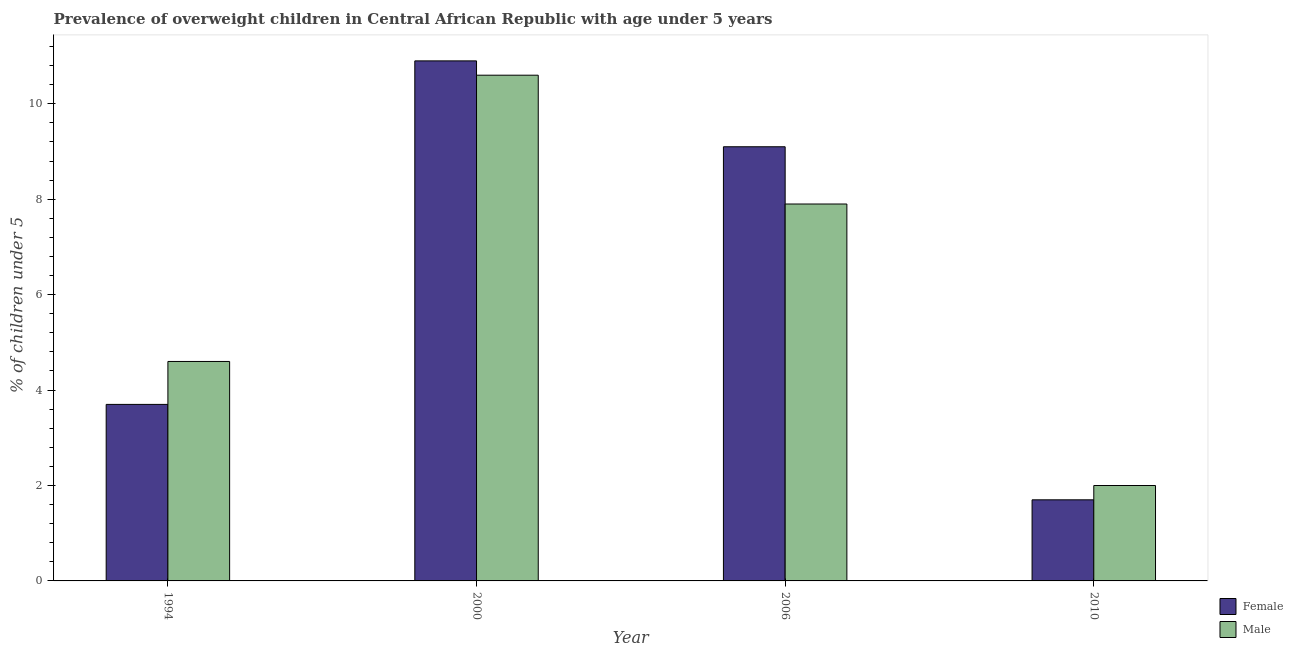How many different coloured bars are there?
Provide a short and direct response. 2. Are the number of bars per tick equal to the number of legend labels?
Make the answer very short. Yes. How many bars are there on the 1st tick from the right?
Ensure brevity in your answer.  2. What is the percentage of obese male children in 1994?
Offer a very short reply. 4.6. Across all years, what is the maximum percentage of obese female children?
Your answer should be very brief. 10.9. In which year was the percentage of obese female children maximum?
Your answer should be very brief. 2000. In which year was the percentage of obese female children minimum?
Ensure brevity in your answer.  2010. What is the total percentage of obese male children in the graph?
Your answer should be compact. 25.1. What is the difference between the percentage of obese male children in 1994 and that in 2010?
Your answer should be compact. 2.6. What is the difference between the percentage of obese male children in 1994 and the percentage of obese female children in 2006?
Keep it short and to the point. -3.3. What is the average percentage of obese male children per year?
Make the answer very short. 6.28. In how many years, is the percentage of obese female children greater than 1.6 %?
Offer a very short reply. 4. What is the ratio of the percentage of obese male children in 2000 to that in 2006?
Make the answer very short. 1.34. What is the difference between the highest and the second highest percentage of obese female children?
Keep it short and to the point. 1.8. What is the difference between the highest and the lowest percentage of obese male children?
Provide a short and direct response. 8.6. What does the 2nd bar from the left in 2006 represents?
Provide a succinct answer. Male. How many bars are there?
Your answer should be compact. 8. Are all the bars in the graph horizontal?
Make the answer very short. No. How many years are there in the graph?
Ensure brevity in your answer.  4. Are the values on the major ticks of Y-axis written in scientific E-notation?
Provide a short and direct response. No. Does the graph contain any zero values?
Keep it short and to the point. No. Does the graph contain grids?
Your answer should be very brief. No. Where does the legend appear in the graph?
Your answer should be compact. Bottom right. What is the title of the graph?
Your answer should be very brief. Prevalence of overweight children in Central African Republic with age under 5 years. What is the label or title of the Y-axis?
Offer a terse response.  % of children under 5. What is the  % of children under 5 in Female in 1994?
Provide a short and direct response. 3.7. What is the  % of children under 5 of Male in 1994?
Offer a terse response. 4.6. What is the  % of children under 5 of Female in 2000?
Provide a succinct answer. 10.9. What is the  % of children under 5 of Male in 2000?
Ensure brevity in your answer.  10.6. What is the  % of children under 5 of Female in 2006?
Provide a short and direct response. 9.1. What is the  % of children under 5 of Male in 2006?
Your response must be concise. 7.9. What is the  % of children under 5 in Female in 2010?
Keep it short and to the point. 1.7. Across all years, what is the maximum  % of children under 5 of Female?
Keep it short and to the point. 10.9. Across all years, what is the maximum  % of children under 5 in Male?
Provide a succinct answer. 10.6. Across all years, what is the minimum  % of children under 5 in Female?
Give a very brief answer. 1.7. What is the total  % of children under 5 of Female in the graph?
Give a very brief answer. 25.4. What is the total  % of children under 5 in Male in the graph?
Provide a short and direct response. 25.1. What is the difference between the  % of children under 5 of Female in 1994 and that in 2000?
Provide a short and direct response. -7.2. What is the difference between the  % of children under 5 of Male in 1994 and that in 2006?
Keep it short and to the point. -3.3. What is the difference between the  % of children under 5 of Male in 1994 and that in 2010?
Provide a short and direct response. 2.6. What is the difference between the  % of children under 5 in Female in 2000 and that in 2006?
Your response must be concise. 1.8. What is the difference between the  % of children under 5 of Male in 2006 and that in 2010?
Offer a terse response. 5.9. What is the difference between the  % of children under 5 of Female in 1994 and the  % of children under 5 of Male in 2006?
Provide a succinct answer. -4.2. What is the difference between the  % of children under 5 of Female in 1994 and the  % of children under 5 of Male in 2010?
Ensure brevity in your answer.  1.7. What is the difference between the  % of children under 5 in Female in 2000 and the  % of children under 5 in Male in 2006?
Provide a succinct answer. 3. What is the difference between the  % of children under 5 in Female in 2006 and the  % of children under 5 in Male in 2010?
Provide a succinct answer. 7.1. What is the average  % of children under 5 of Female per year?
Your answer should be compact. 6.35. What is the average  % of children under 5 in Male per year?
Your answer should be very brief. 6.28. In the year 1994, what is the difference between the  % of children under 5 in Female and  % of children under 5 in Male?
Your response must be concise. -0.9. What is the ratio of the  % of children under 5 of Female in 1994 to that in 2000?
Offer a terse response. 0.34. What is the ratio of the  % of children under 5 of Male in 1994 to that in 2000?
Your answer should be very brief. 0.43. What is the ratio of the  % of children under 5 of Female in 1994 to that in 2006?
Your answer should be compact. 0.41. What is the ratio of the  % of children under 5 in Male in 1994 to that in 2006?
Give a very brief answer. 0.58. What is the ratio of the  % of children under 5 in Female in 1994 to that in 2010?
Ensure brevity in your answer.  2.18. What is the ratio of the  % of children under 5 of Male in 1994 to that in 2010?
Offer a terse response. 2.3. What is the ratio of the  % of children under 5 of Female in 2000 to that in 2006?
Your answer should be compact. 1.2. What is the ratio of the  % of children under 5 of Male in 2000 to that in 2006?
Provide a short and direct response. 1.34. What is the ratio of the  % of children under 5 of Female in 2000 to that in 2010?
Offer a very short reply. 6.41. What is the ratio of the  % of children under 5 of Male in 2000 to that in 2010?
Keep it short and to the point. 5.3. What is the ratio of the  % of children under 5 in Female in 2006 to that in 2010?
Give a very brief answer. 5.35. What is the ratio of the  % of children under 5 in Male in 2006 to that in 2010?
Make the answer very short. 3.95. What is the difference between the highest and the second highest  % of children under 5 of Male?
Your response must be concise. 2.7. 